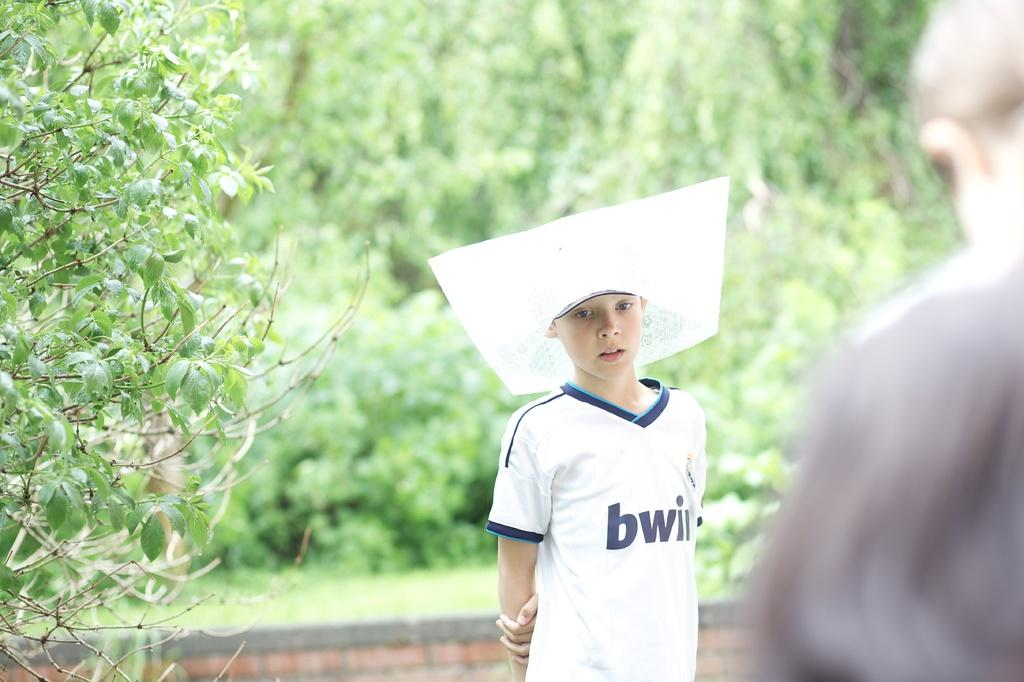Who is the main subject in the image? There is a small girl in the center of the image. Can you describe the other person in the image? There is a man on the right side of the image. What can be seen in the background of the image? There are trees in the background of the image. What type of blade is being used by the ghost in the image? There is no ghost present in the image, and therefore no blade is being used. 